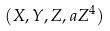<formula> <loc_0><loc_0><loc_500><loc_500>( X , Y , Z , a Z ^ { 4 } )</formula> 